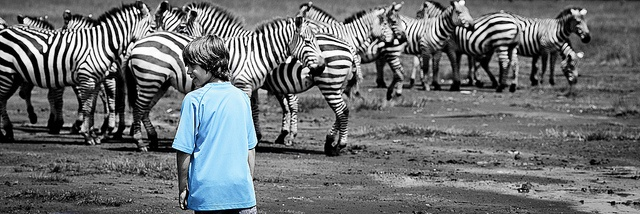Describe the objects in this image and their specific colors. I can see people in gray, lightblue, and black tones, zebra in gray, white, black, and darkgray tones, zebra in gray, black, white, and darkgray tones, zebra in gray, black, darkgray, and lightgray tones, and zebra in gray, black, lightgray, and darkgray tones in this image. 